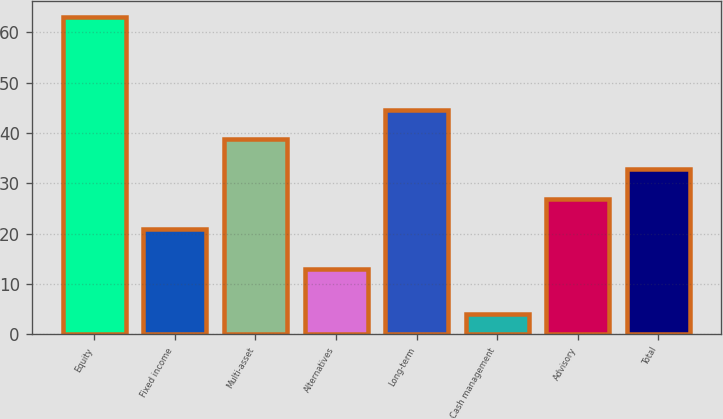Convert chart. <chart><loc_0><loc_0><loc_500><loc_500><bar_chart><fcel>Equity<fcel>Fixed income<fcel>Multi-asset<fcel>Alternatives<fcel>Long-term<fcel>Cash management<fcel>Advisory<fcel>Total<nl><fcel>63<fcel>21<fcel>38.7<fcel>13<fcel>44.6<fcel>4<fcel>26.9<fcel>32.8<nl></chart> 